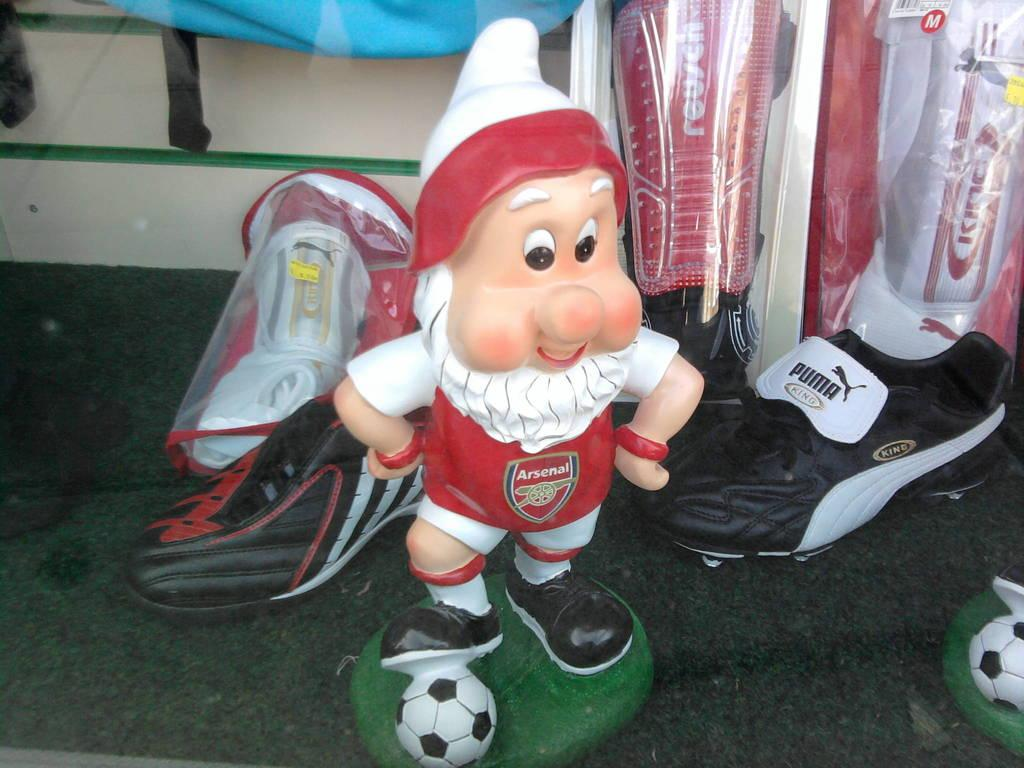What is the main subject of the image? There is a doll in the image. What type of footwear is visible in the image? There are shoes in the image. What additional accessory is present in the image? There are leg pads in the image. What type of downtown scene can be seen in the image? There is no downtown scene present in the image; it features a doll, shoes, and leg pads. What type of humor is depicted in the image? There is no humor depicted in the image; it is a straightforward representation of a doll, shoes, and leg pads. 